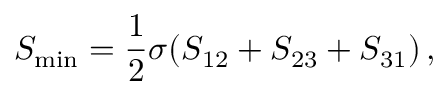Convert formula to latex. <formula><loc_0><loc_0><loc_500><loc_500>S _ { \min } = { \frac { 1 } { 2 } } \sigma ( S _ { 1 2 } + S _ { 2 3 } + S _ { 3 1 } ) \, ,</formula> 